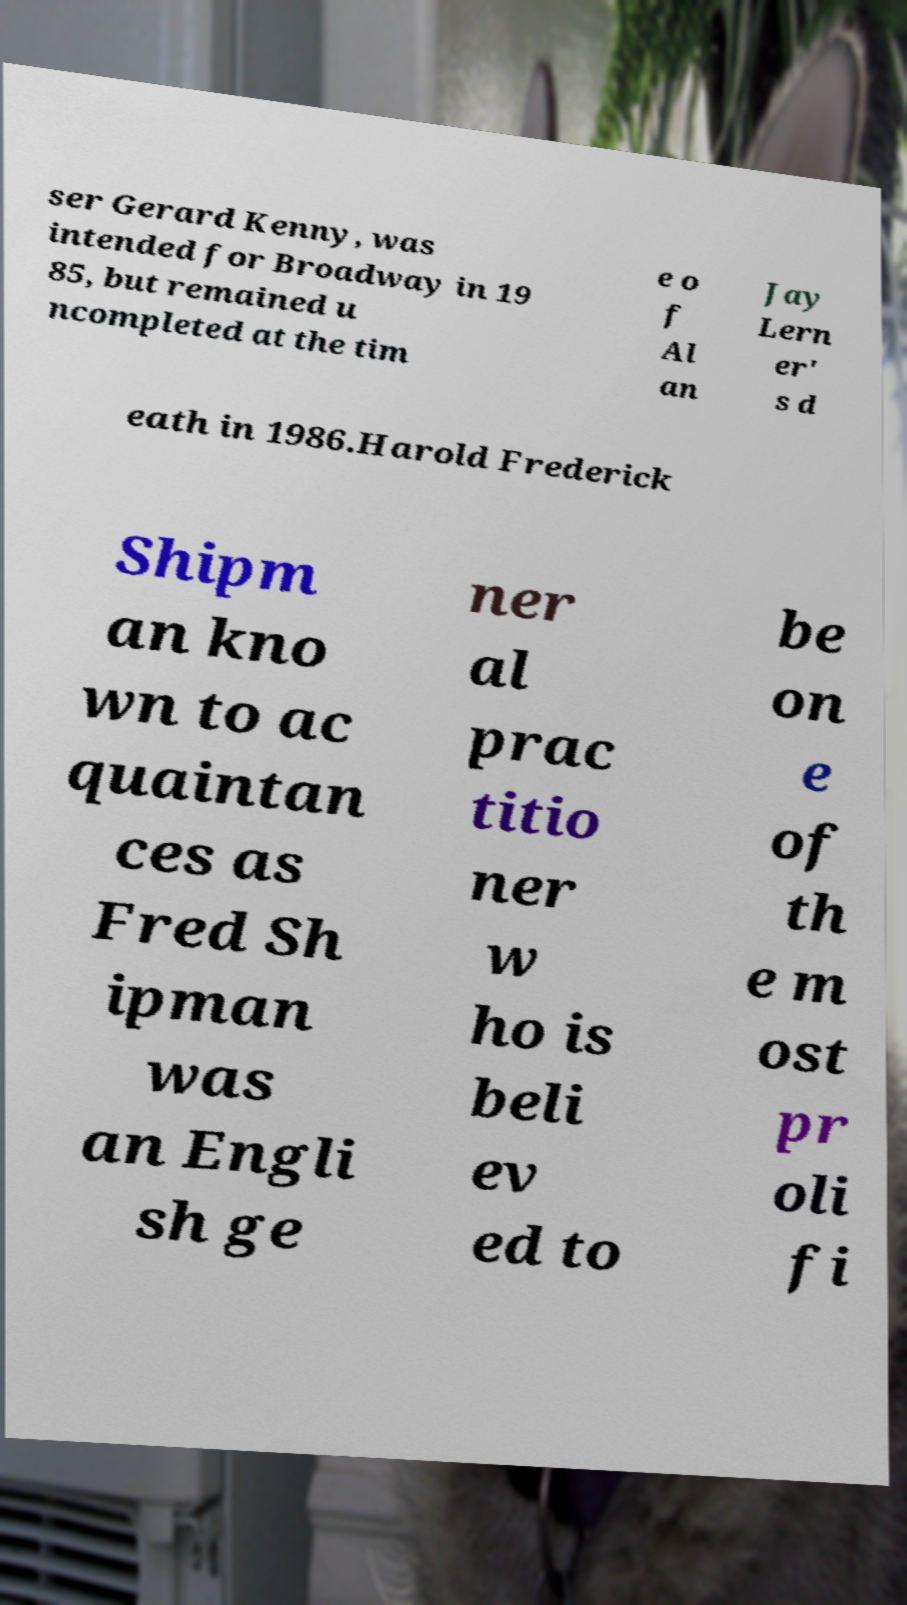What messages or text are displayed in this image? I need them in a readable, typed format. ser Gerard Kenny, was intended for Broadway in 19 85, but remained u ncompleted at the tim e o f Al an Jay Lern er' s d eath in 1986.Harold Frederick Shipm an kno wn to ac quaintan ces as Fred Sh ipman was an Engli sh ge ner al prac titio ner w ho is beli ev ed to be on e of th e m ost pr oli fi 